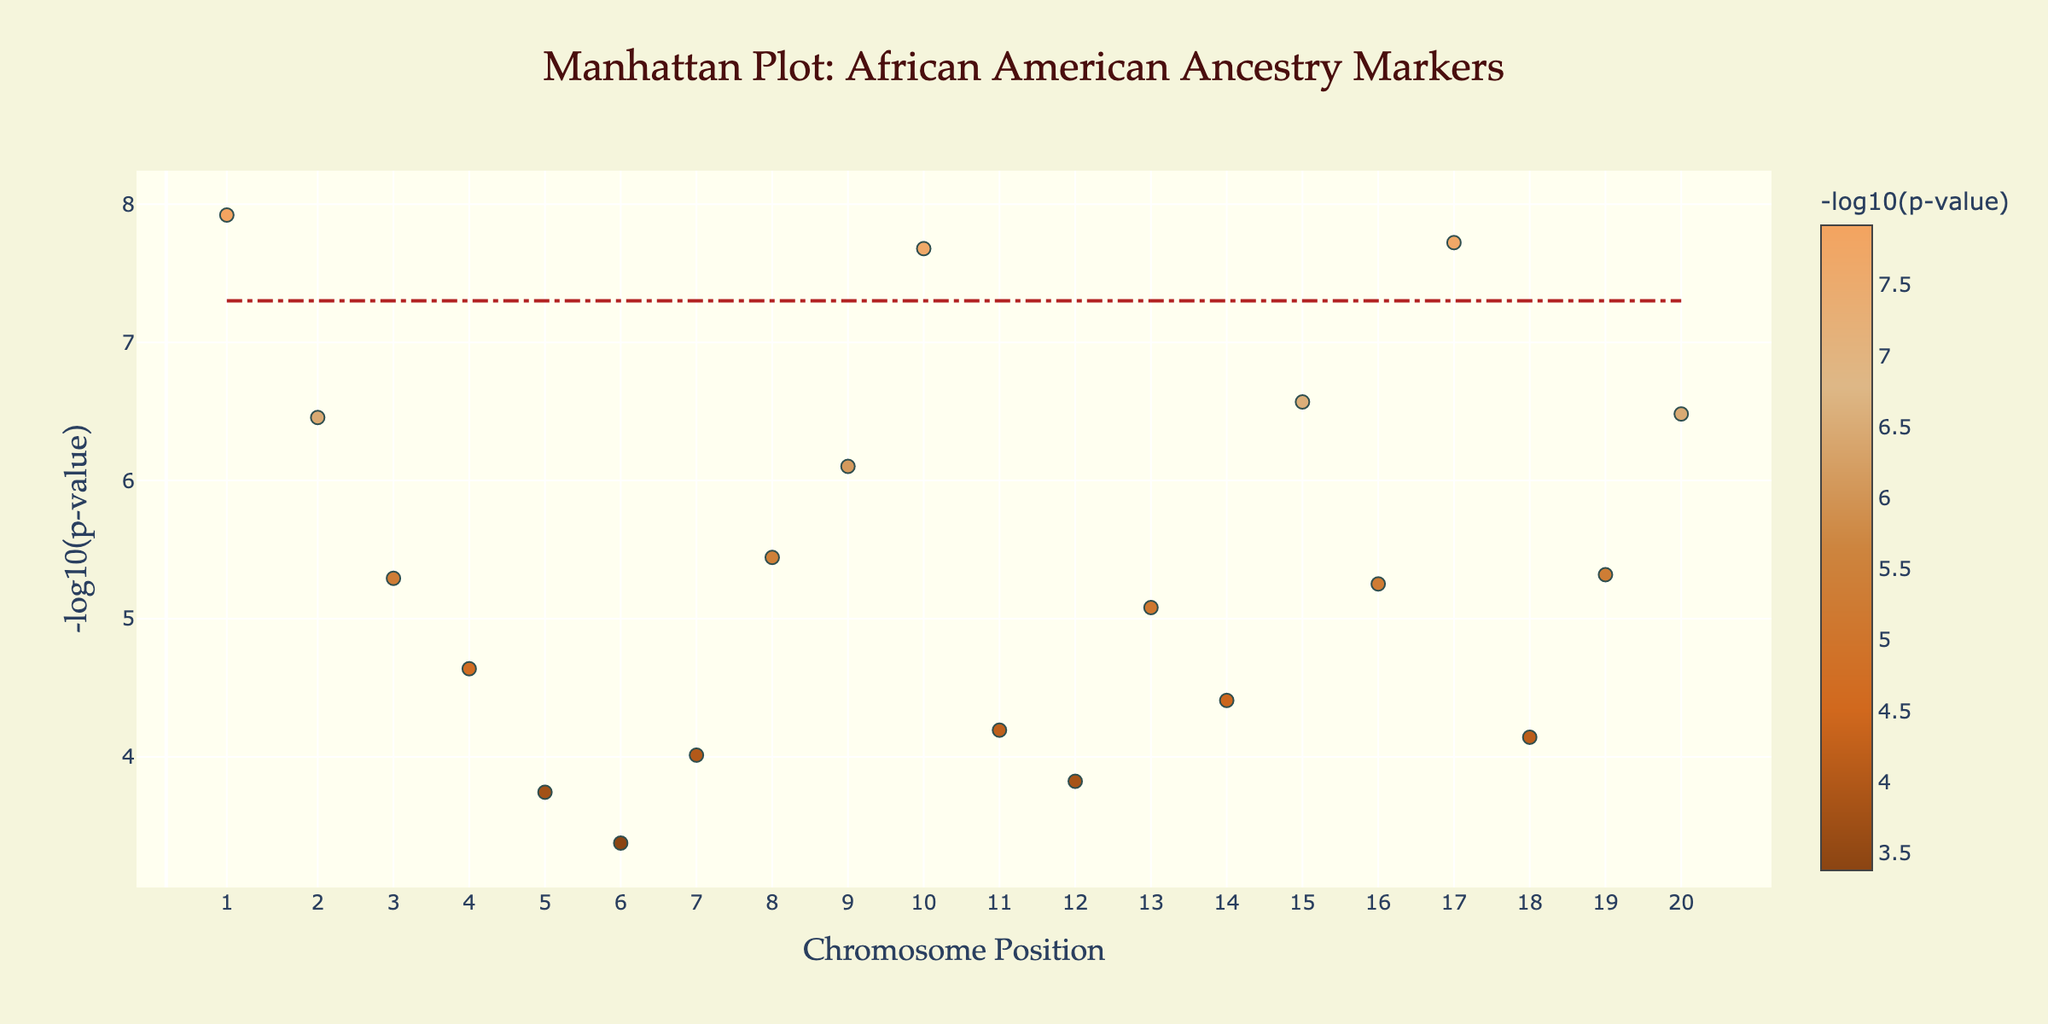What's the title of the figure? The title is located at the top of the figure. It reads "Manhattan Plot: African American Ancestry Markers".
Answer: Manhattan Plot: African American Ancestry Markers What is represented on the x-axis? The x-axis title gives away the key information. It's labeled "Chromosome Position", representing the positions along different chromosomes.
Answer: Chromosome Position What does the y-axis represent? The y-axis is labeled "-log10(p-value)", indicating it shows the negative log-transformed p-values of the genetic markers.
Answer: -log10(p-value) Which data point has the lowest p-value? To find the lowest p-value, look at the highest y-value since y represents -log10(p-value). The highest data point corresponds to "rs2814778 in Louisiana".
Answer: rs2814778 in Louisiana How many data points have a p-value below 5e-8? Identify the line labeled as the significance threshold at -log10(5e-8). The data points above this line are significant. There are 2: "rs2814778 in Louisiana" and "rs1426654 in North Carolina".
Answer: 2 Which two regions have the most significant p-values? To determine this, observe the highest data points (those furthest up on the y-axis). They correspond to Louisiana (rs2814778) and North Carolina (rs1426654).
Answer: Louisiana and North Carolina What is the range of Chromosome positions represented in the plot? The lowest position is on the left end and the highest position is on the right end of the x-axis. The positions range from 1,000,000 to 25,000,000.
Answer: 1,000,000 to 25,000,000 Which region has an SNP at position 20,000,000? Find the data point around position 20,000,000 on the x-axis and look at the hover text for its region. It corresponds to rs1800407 in Washington D.C.
Answer: Washington D.C Which SNP has a p-value close to 1e-6? Locate the y-values around -log10(1e-6), which is 6. There are two SNPs close to this value: rs2572307 in Georgia and rs3827760 in Kentucky.
Answer: rs2572307 in Georgia How many SNPs are associated with regions in the Southern U.S.? Identify the regions traditionally considered Southern states (e.g., Louisiana, South Carolina, Georgia, Mississippi, Alabama, Virginia, Texas, and Florida). There are 8 data points.
Answer: 8 